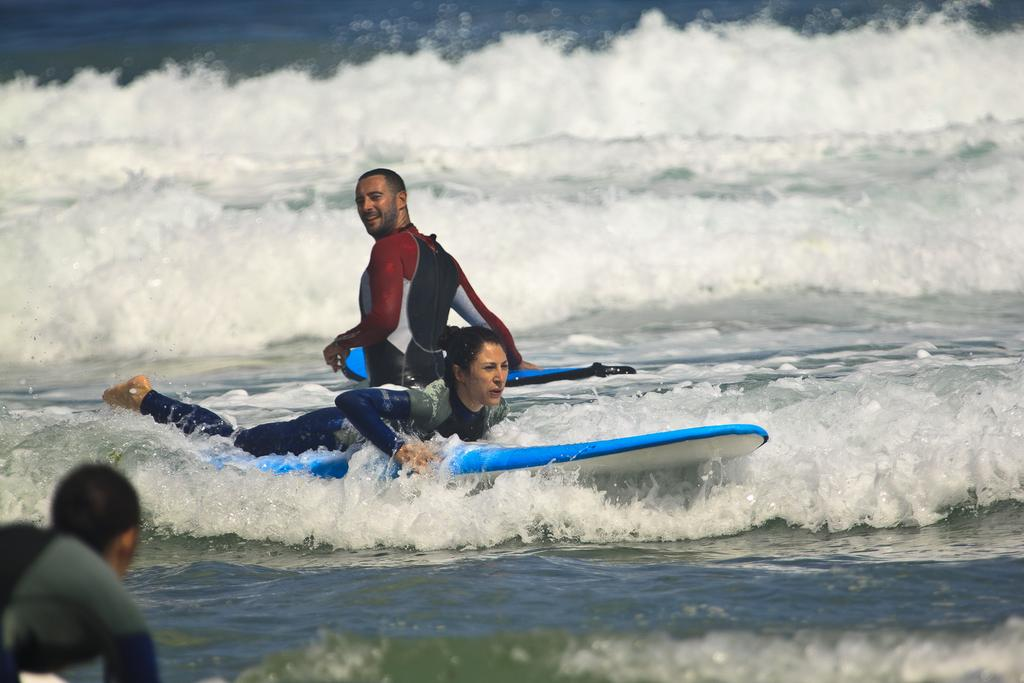Where is the image taken? The image is taken on the sea. What is the woman in the image doing? The woman is surfing on a board. What color is the woman's suit? The woman is wearing a blue suit. What is the man in the image doing? The man is standing and holding a board. What can be seen in the background of the image? There is water visible in the image. Can you tell me how many snails are crawling on the cushion in the image? There are no snails or cushions present in the image; it features a woman surfing and a man holding a board on the sea. 